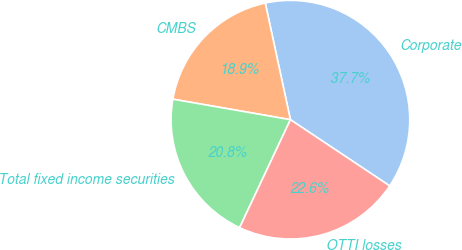Convert chart to OTSL. <chart><loc_0><loc_0><loc_500><loc_500><pie_chart><fcel>Corporate<fcel>CMBS<fcel>Total fixed income securities<fcel>OTTI losses<nl><fcel>37.74%<fcel>18.87%<fcel>20.75%<fcel>22.64%<nl></chart> 